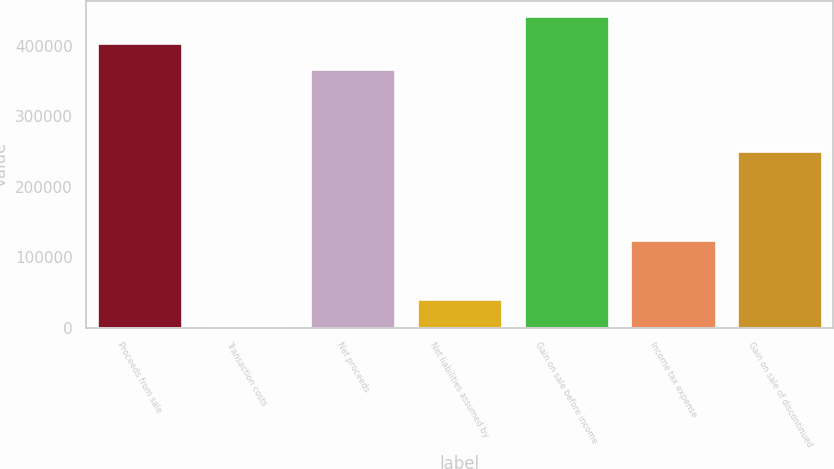Convert chart to OTSL. <chart><loc_0><loc_0><loc_500><loc_500><bar_chart><fcel>Proceeds from sale<fcel>Transaction costs<fcel>Net proceeds<fcel>Net liabilities assumed by<fcel>Gain on sale before income<fcel>Income tax expense<fcel>Gain on sale of discontinued<nl><fcel>404426<fcel>2778<fcel>367222<fcel>39982.4<fcel>441631<fcel>124249<fcel>250573<nl></chart> 